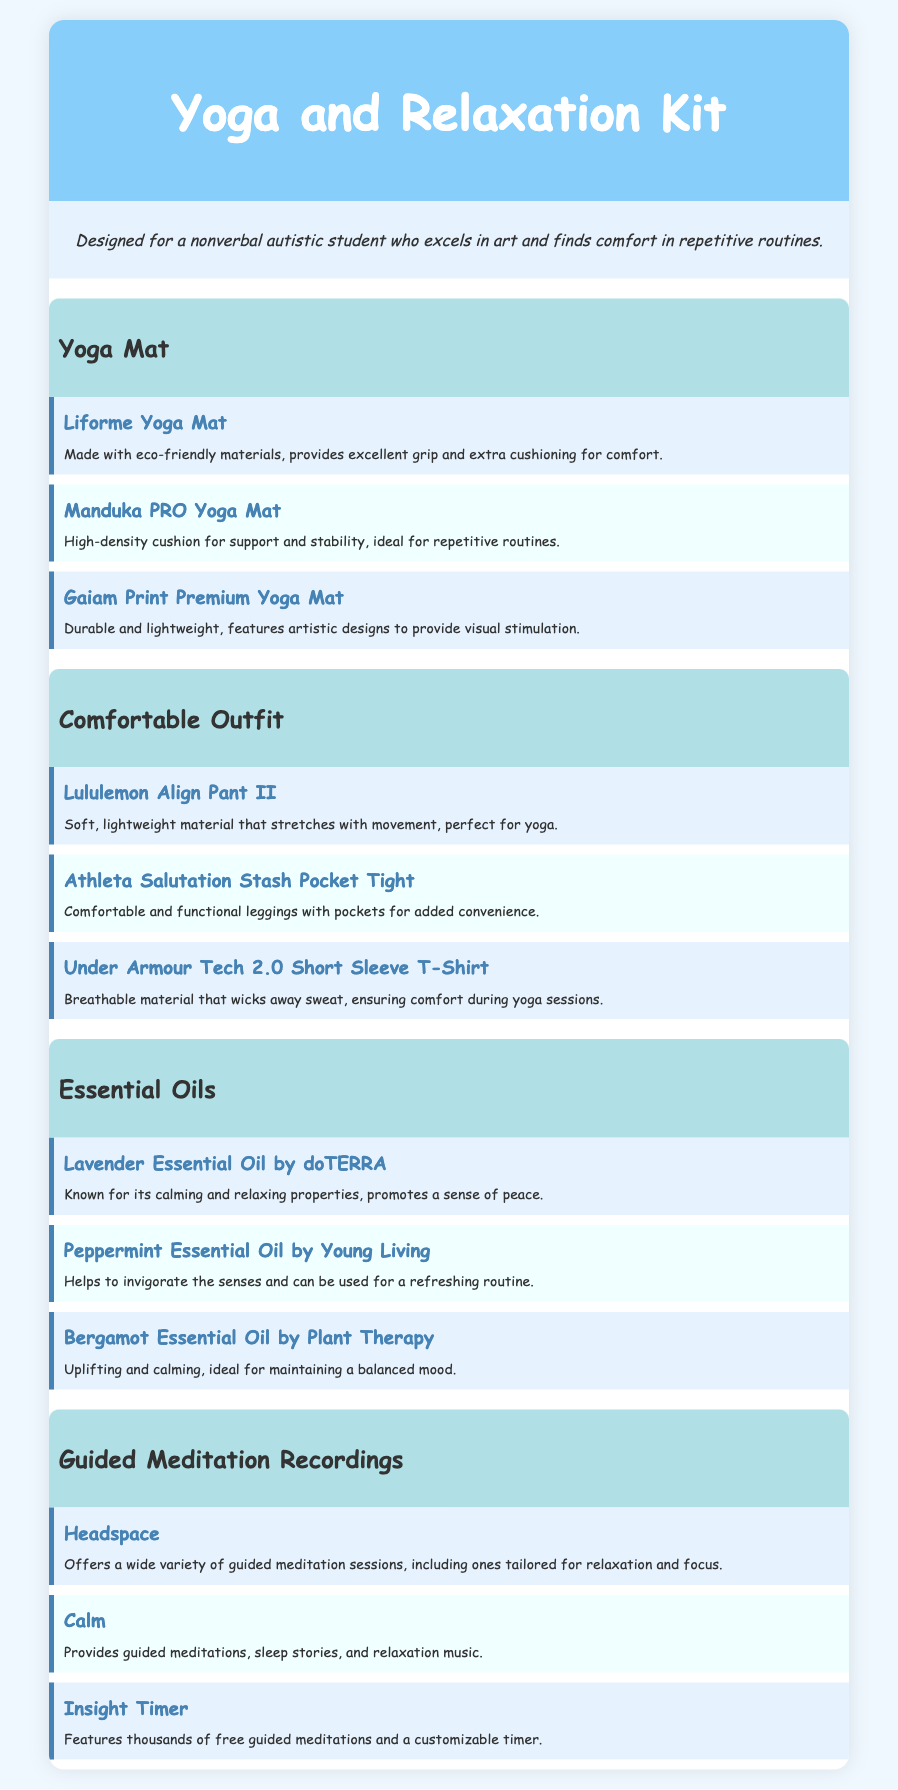What are the three categories listed in the packing list? The document describes four categories of items in the packing list: Yoga Mat, Comfortable Outfit, Essential Oils, and Guided Meditation Recordings.
Answer: Yoga Mat, Comfortable Outfit, Essential Oils, Guided Meditation Recordings What is one type of essential oil mentioned in the document? The document lists three different essential oils with their descriptions. An example is Lavender Essential Oil by doTERRA.
Answer: Lavender Essential Oil by doTERRA Which yoga mat is known for its eco-friendly materials? The document includes different yoga mats and specifies Liforme Yoga Mat for its eco-friendly attributes.
Answer: Liforme Yoga Mat What is the primary purpose of Lavender Essential Oil? The document states that Lavender Essential Oil is known for its calming and relaxing properties.
Answer: Calming What type of recording does Headspace offer? The document mentions that Headspace provides guided meditation sessions tailored for relaxation and focus.
Answer: Guided meditation sessions How many guided meditation recordings are listed in the document? The document lists a total of three guided meditation resources under the category of Guided Meditation Recordings.
Answer: Three What type of material are the Lululemon Align Pant II made of? The document describes the material of the Lululemon Align Pant II as soft and lightweight.
Answer: Soft, lightweight Which category would you find the Manduka PRO Yoga Mat? The Manduka PRO Yoga Mat belongs to the category specifically labeled Yoga Mat in the document.
Answer: Yoga Mat 